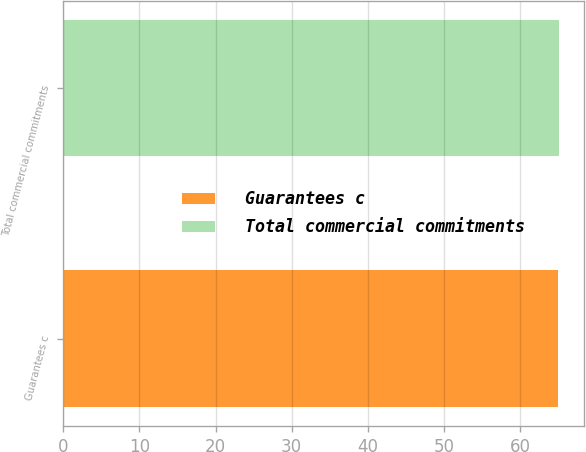Convert chart. <chart><loc_0><loc_0><loc_500><loc_500><bar_chart><fcel>Guarantees c<fcel>Total commercial commitments<nl><fcel>65<fcel>65.1<nl></chart> 